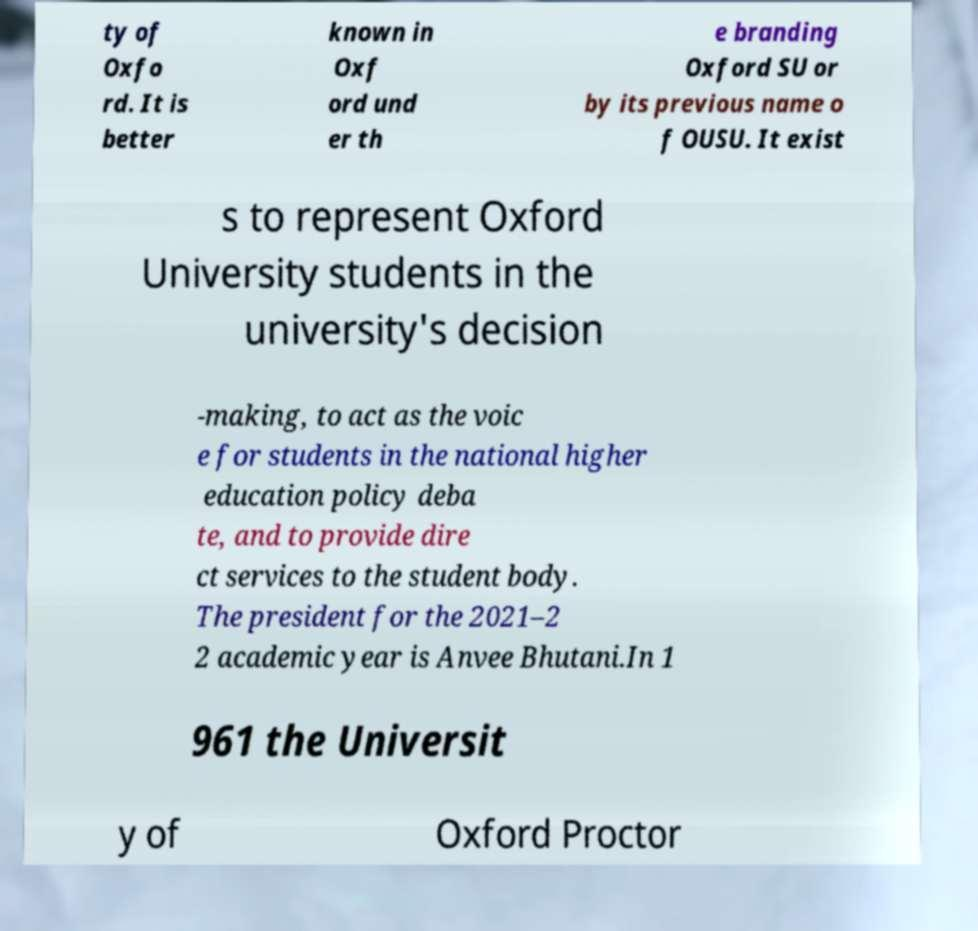What messages or text are displayed in this image? I need them in a readable, typed format. ty of Oxfo rd. It is better known in Oxf ord und er th e branding Oxford SU or by its previous name o f OUSU. It exist s to represent Oxford University students in the university's decision -making, to act as the voic e for students in the national higher education policy deba te, and to provide dire ct services to the student body. The president for the 2021–2 2 academic year is Anvee Bhutani.In 1 961 the Universit y of Oxford Proctor 